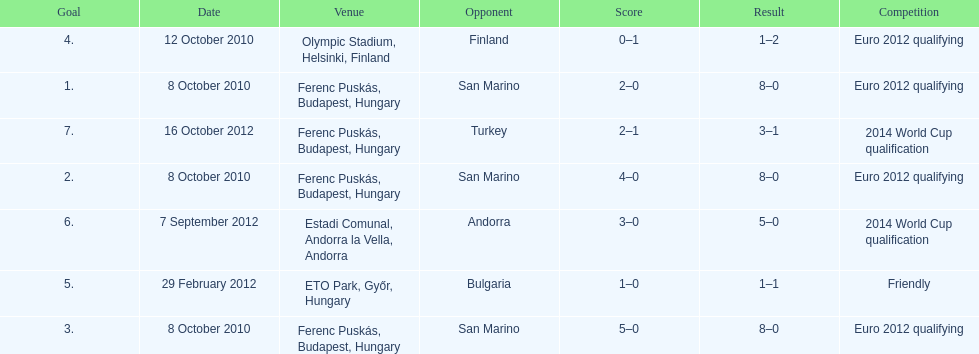What is the total number of international goals ádám szalai has made? 7. 